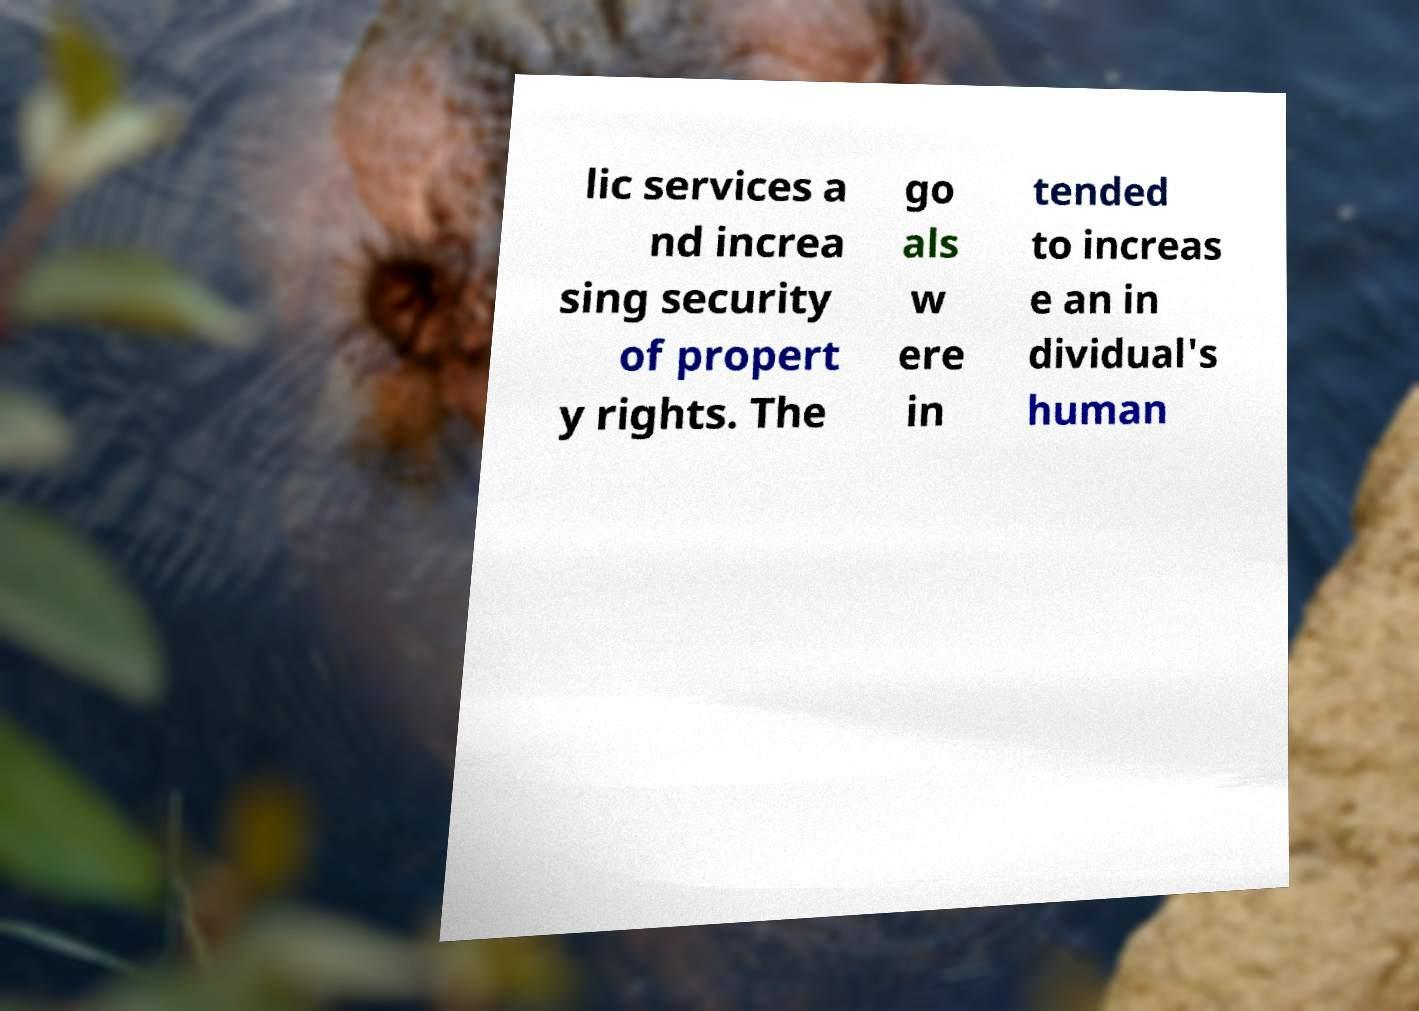Can you read and provide the text displayed in the image?This photo seems to have some interesting text. Can you extract and type it out for me? lic services a nd increa sing security of propert y rights. The go als w ere in tended to increas e an in dividual's human 